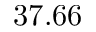<formula> <loc_0><loc_0><loc_500><loc_500>3 7 . 6 6</formula> 